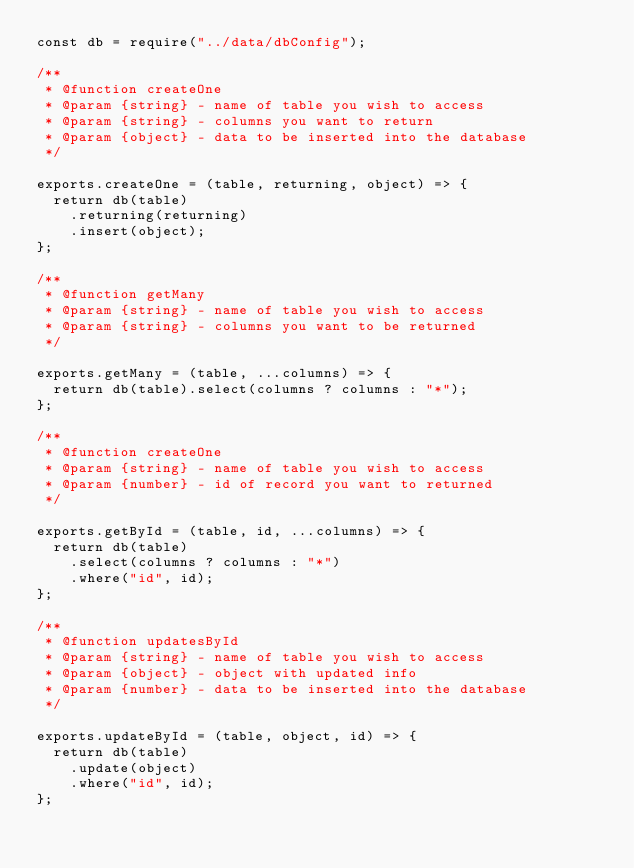<code> <loc_0><loc_0><loc_500><loc_500><_JavaScript_>const db = require("../data/dbConfig");

/**
 * @function createOne
 * @param {string} - name of table you wish to access
 * @param {string} - columns you want to return
 * @param {object} - data to be inserted into the database
 */

exports.createOne = (table, returning, object) => {
  return db(table)
    .returning(returning)
    .insert(object);
};

/**
 * @function getMany
 * @param {string} - name of table you wish to access
 * @param {string} - columns you want to be returned
 */

exports.getMany = (table, ...columns) => {
  return db(table).select(columns ? columns : "*");
};

/**
 * @function createOne
 * @param {string} - name of table you wish to access
 * @param {number} - id of record you want to returned
 */

exports.getById = (table, id, ...columns) => {
  return db(table)
    .select(columns ? columns : "*")
    .where("id", id);
};

/**
 * @function updatesById
 * @param {string} - name of table you wish to access
 * @param {object} - object with updated info
 * @param {number} - data to be inserted into the database
 */

exports.updateById = (table, object, id) => {
  return db(table)
    .update(object)
    .where("id", id);
};
</code> 